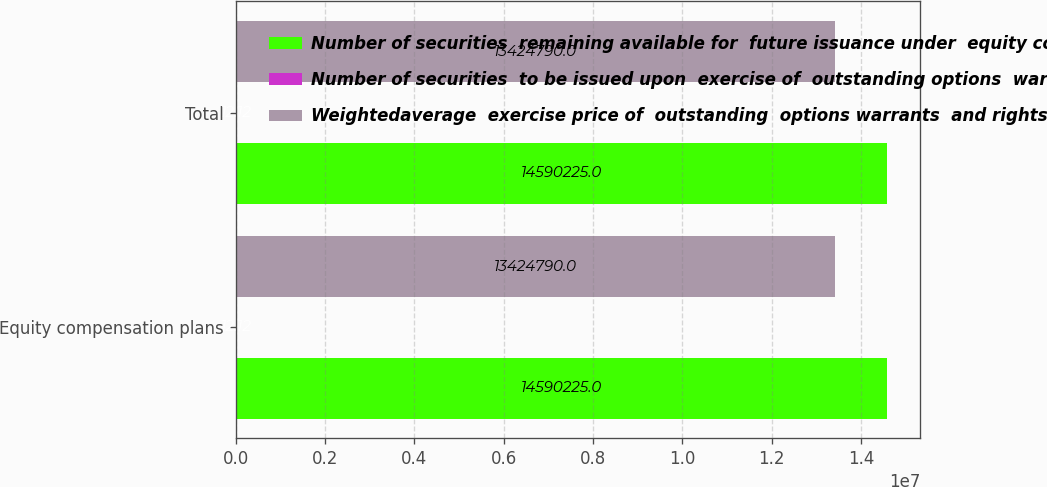Convert chart to OTSL. <chart><loc_0><loc_0><loc_500><loc_500><stacked_bar_chart><ecel><fcel>Equity compensation plans<fcel>Total<nl><fcel>Number of securities  remaining available for  future issuance under  equity compensation plans  excluding securities  reflected in column a  c<fcel>1.45902e+07<fcel>1.45902e+07<nl><fcel>Number of securities  to be issued upon  exercise of  outstanding options  warrants and rights  a<fcel>12.12<fcel>12.12<nl><fcel>Weightedaverage  exercise price of  outstanding  options warrants  and rights  b<fcel>1.34248e+07<fcel>1.34248e+07<nl></chart> 